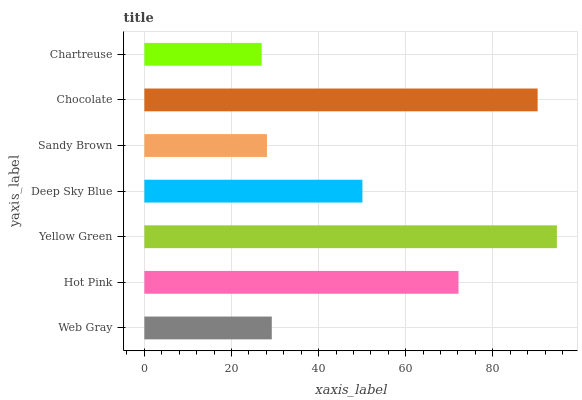Is Chartreuse the minimum?
Answer yes or no. Yes. Is Yellow Green the maximum?
Answer yes or no. Yes. Is Hot Pink the minimum?
Answer yes or no. No. Is Hot Pink the maximum?
Answer yes or no. No. Is Hot Pink greater than Web Gray?
Answer yes or no. Yes. Is Web Gray less than Hot Pink?
Answer yes or no. Yes. Is Web Gray greater than Hot Pink?
Answer yes or no. No. Is Hot Pink less than Web Gray?
Answer yes or no. No. Is Deep Sky Blue the high median?
Answer yes or no. Yes. Is Deep Sky Blue the low median?
Answer yes or no. Yes. Is Web Gray the high median?
Answer yes or no. No. Is Yellow Green the low median?
Answer yes or no. No. 